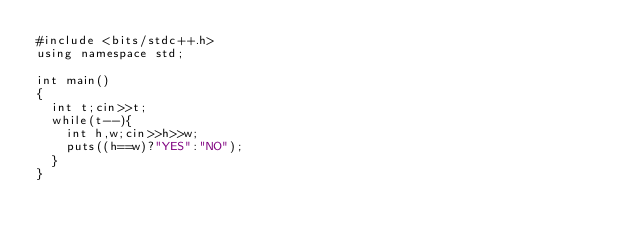Convert code to text. <code><loc_0><loc_0><loc_500><loc_500><_C++_>#include <bits/stdc++.h>
using namespace std;

int main()
{
	int t;cin>>t;
	while(t--){
		int h,w;cin>>h>>w;
		puts((h==w)?"YES":"NO");
	}
}</code> 